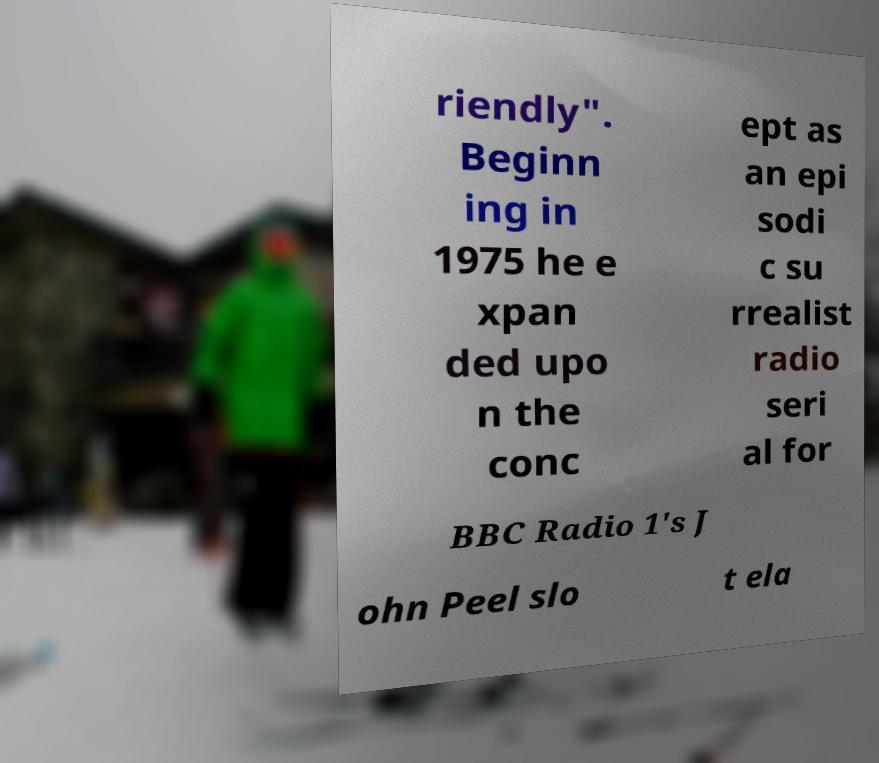For documentation purposes, I need the text within this image transcribed. Could you provide that? riendly". Beginn ing in 1975 he e xpan ded upo n the conc ept as an epi sodi c su rrealist radio seri al for BBC Radio 1's J ohn Peel slo t ela 